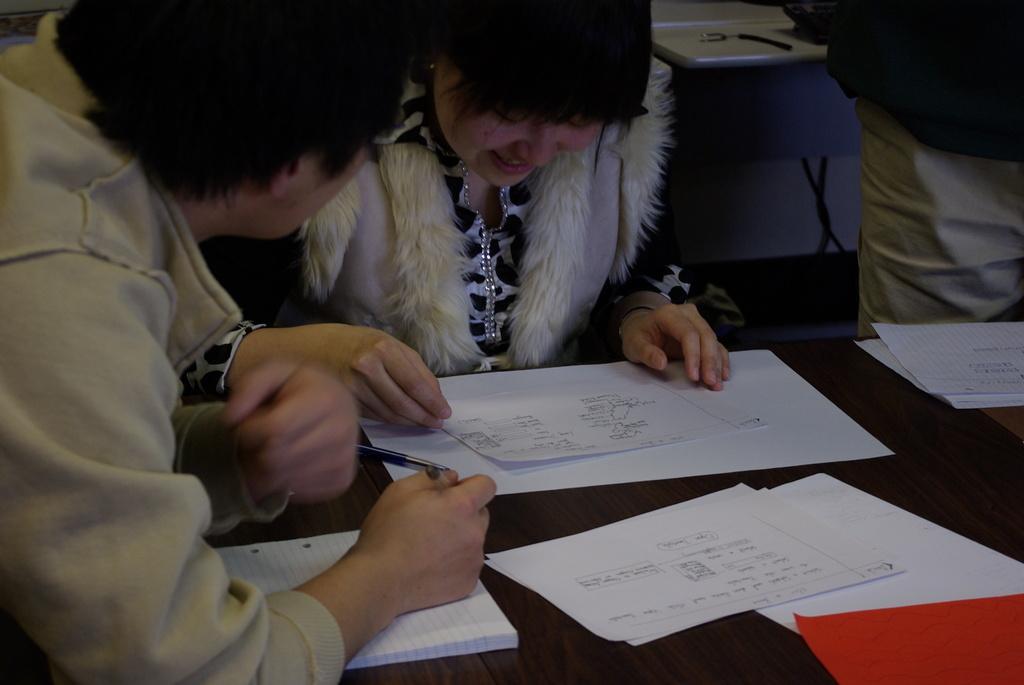Please provide a concise description of this image. In this image there are a few people sitting and standing, in front of them there is a table. On the table there is a book and few papers, one of them is holding a pen in his hand, behind them there is an object on the other table. 